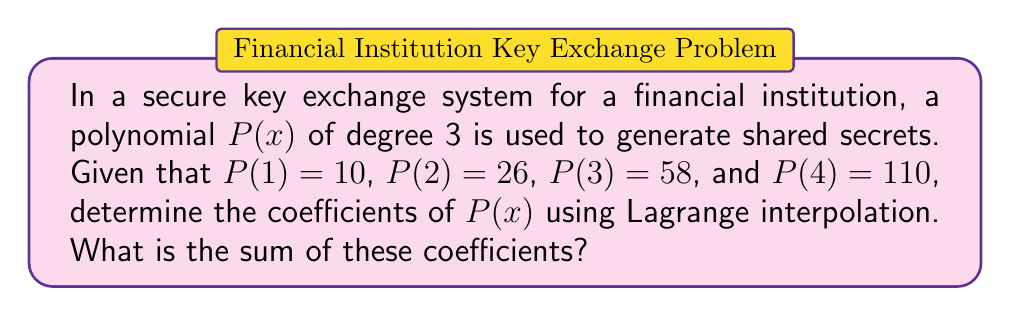Help me with this question. To solve this problem, we'll use Lagrange interpolation to find the polynomial $P(x)$ and then sum its coefficients.

1) The Lagrange interpolation formula for a polynomial of degree 3 is:

   $$P(x) = \sum_{i=1}^4 y_i \prod_{j \neq i} \frac{x - x_j}{x_i - x_j}$$

2) We have the following points: (1, 10), (2, 26), (3, 58), (4, 110)

3) Let's calculate each term:

   For $i = 1$: 
   $$L_1(x) = 10 \cdot \frac{(x-2)(x-3)(x-4)}{(1-2)(1-3)(1-4)} = \frac{10(x-2)(x-3)(x-4)}{-6}$$

   For $i = 2$:
   $$L_2(x) = 26 \cdot \frac{(x-1)(x-3)(x-4)}{(2-1)(2-3)(2-4)} = \frac{-26(x-1)(x-3)(x-4)}{2}$$

   For $i = 3$:
   $$L_3(x) = 58 \cdot \frac{(x-1)(x-2)(x-4)}{(3-1)(3-2)(3-4)} = \frac{29(x-1)(x-2)(x-4)}{2}$$

   For $i = 4$:
   $$L_4(x) = 110 \cdot \frac{(x-1)(x-2)(x-3)}{(4-1)(4-2)(4-3)} = \frac{110(x-1)(x-2)(x-3)}{6}$$

4) Sum these terms:

   $$P(x) = L_1(x) + L_2(x) + L_3(x) + L_4(x)$$

5) Expand and simplify:

   $$P(x) = \frac{-10x^3+60x^2-110x+60}{6} + \frac{26x^3-156x^2+286x-156}{2} + \frac{29x^3-174x^2+319x-174}{2} + \frac{110x^3-660x^2+1210x-660}{6}$$

6) Combine like terms:

   $$P(x) = x^3 + 5x^2 + 3x + 1$$

7) The coefficients are 1, 5, 3, and 1.

8) Sum the coefficients:

   $$1 + 5 + 3 + 1 = 10$$
Answer: $10$ 